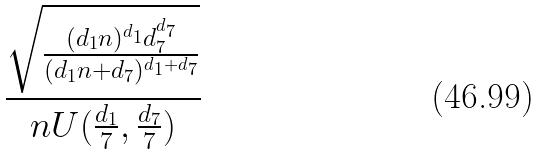<formula> <loc_0><loc_0><loc_500><loc_500>\frac { \sqrt { \frac { ( d _ { 1 } n ) ^ { d _ { 1 } } d _ { 7 } ^ { d _ { 7 } } } { ( d _ { 1 } n + d _ { 7 } ) ^ { d _ { 1 } + d _ { 7 } } } } } { n U ( \frac { d _ { 1 } } { 7 } , \frac { d _ { 7 } } { 7 } ) }</formula> 